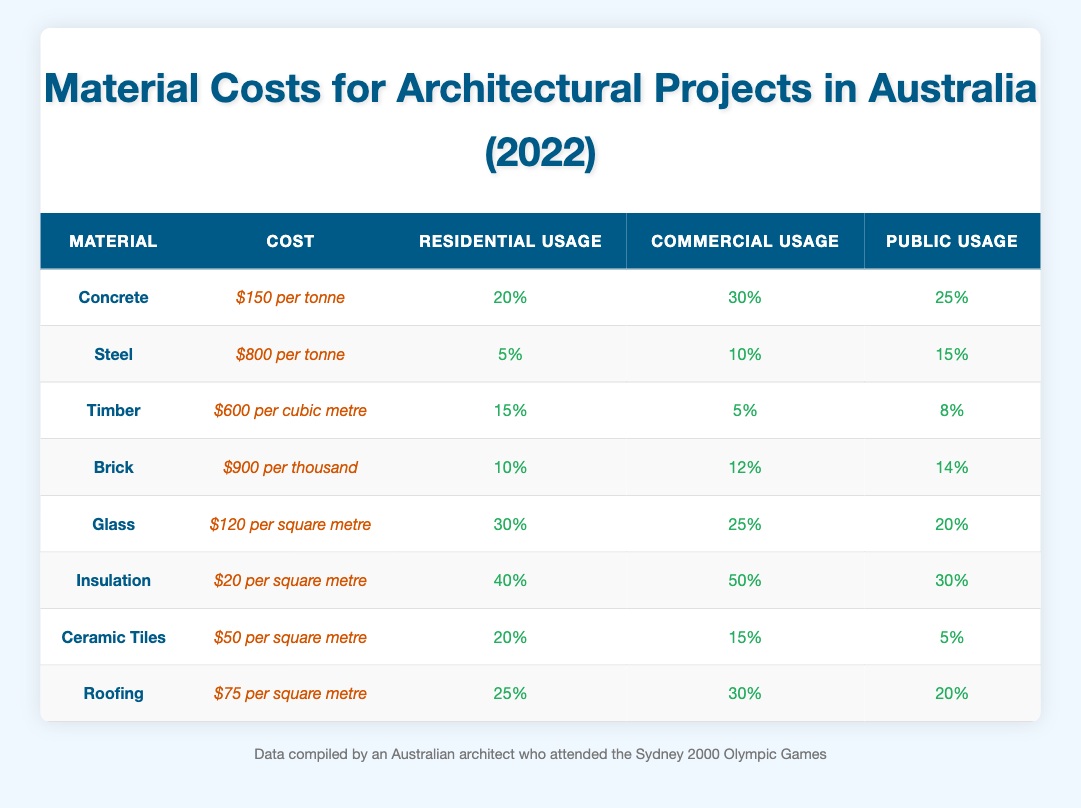What's the cost of Concrete per tonne? The table lists the cost for Concrete under the 'Cost' column, which states it is $150 per tonne.
Answer: $150 per tonne Which material has the highest cost per tonne? By comparing the costs listed for each material, Steel has the highest cost at $800 per tonne.
Answer: Steel How much more Insulation is used in Commercial Projects compared to Public Projects? Insulation usage in Commercial Projects is 50% while in Public Projects it is 30%. The difference is calculated as 50% - 30% = 20%.
Answer: 20% What is the average usage of Glass in all project types? The usages are 30% (Residential), 25% (Commercial), and 20% (Public). The average is found by summing these and dividing by 3: (30 + 25 + 20) / 3 = 25%.
Answer: 25% Is the usage of Timber greater in Residential Projects than in Commercial Projects? The usage of Timber is 15% in Residential Projects and 5% in Commercial Projects. Since 15% is greater than 5%, the statement is true.
Answer: Yes Which material has the least usage in Commercial Projects? By examining the 'Commercial Usage' values, Timber has the least usage at 5%.
Answer: Timber What is the total usage of Insulation across all project types? The usage percentages of Insulation are 40% (Residential), 50% (Commercial), and 30% (Public). The total is calculated by adding these: 40% + 50% + 30% = 120%.
Answer: 120% What is the difference in cost between Brick and Ceramic Tiles per square metre? Brick costs $900 per thousand bricks, which translates to approximately $0.90 per brick, and there are around 1000 bricks in a standard square meter. Ceramic Tiles cost $50 per square metre. The difference is approximately $0.90 - $50 = -$49.10.
Answer: $49.10 cheaper for Ceramic Tiles In which project type is Concrete usage the highest? The table shows Concrete usage as 20% (Residential), 30% (Commercial), and 25% (Public). The highest usage is found in Commercial Projects at 30%.
Answer: Commercial Projects 